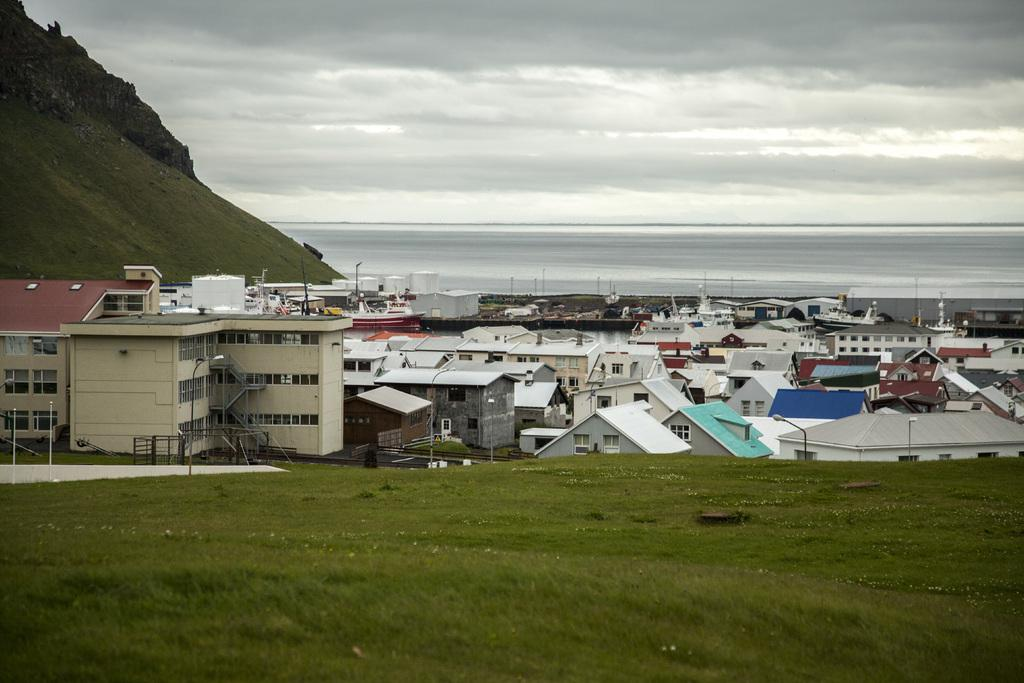What is the setting of the image? The image is an outside view. What structures can be seen in the image? There are buildings in the middle of the image. What natural feature is present in the top left of the image? There is a hill in the top left of the image. What is visible at the top of the image? The sky is visible at the top of the image. What design does the father have on his shirt in the image? There is no father present in the image, so there is no shirt design to describe. 